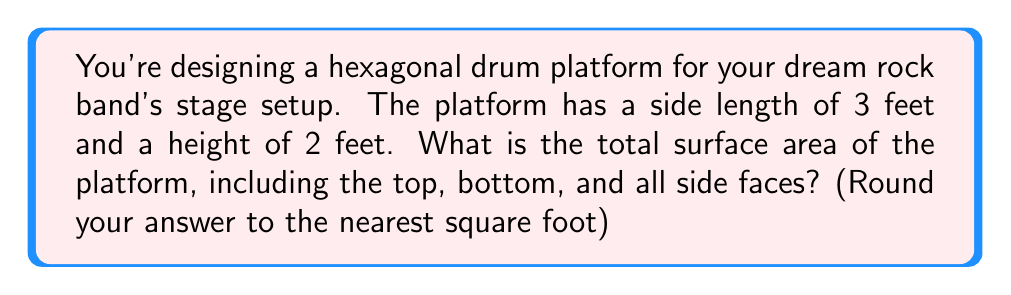Help me with this question. Let's break this down step-by-step:

1) First, we need to calculate the area of the hexagonal top and bottom faces.
   The area of a regular hexagon is given by the formula:
   $$A_{hexagon} = \frac{3\sqrt{3}}{2}s^2$$
   where $s$ is the side length.

   With $s = 3$ feet:
   $$A_{hexagon} = \frac{3\sqrt{3}}{2}(3^2) = \frac{27\sqrt{3}}{2} \approx 23.38 \text{ sq ft}$$

2) Now, we need to calculate the area of the six rectangular side faces.
   Each rectangle has a width equal to the side length of the hexagon (3 feet) and a height of 2 feet.
   Area of one rectangle: $A_{rectangle} = 3 \times 2 = 6 \text{ sq ft}$
   
   Total area of side faces: $6 \times 6 = 36 \text{ sq ft}$

3) The total surface area is the sum of the areas of the top, bottom, and all side faces:
   $$SA_{total} = 2A_{hexagon} + 6A_{rectangle}$$
   $$SA_{total} = 2(\frac{27\sqrt{3}}{2}) + 6(6)$$
   $$SA_{total} = 27\sqrt{3} + 36$$
   $$SA_{total} \approx 46.76 + 36 = 82.76 \text{ sq ft}$$

4) Rounding to the nearest square foot:
   $$SA_{total} \approx 83 \text{ sq ft}$$
Answer: 83 sq ft 